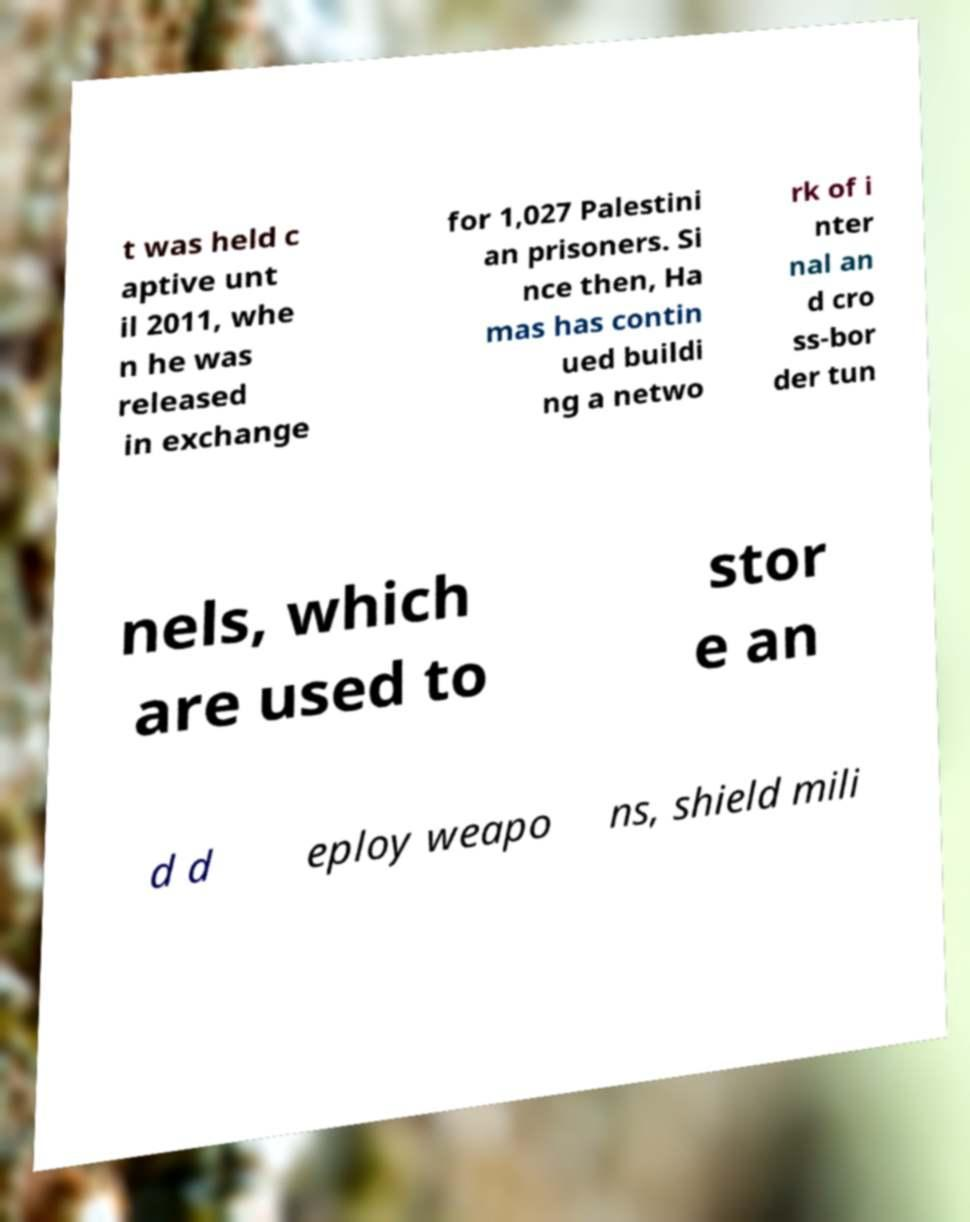Could you assist in decoding the text presented in this image and type it out clearly? t was held c aptive unt il 2011, whe n he was released in exchange for 1,027 Palestini an prisoners. Si nce then, Ha mas has contin ued buildi ng a netwo rk of i nter nal an d cro ss-bor der tun nels, which are used to stor e an d d eploy weapo ns, shield mili 